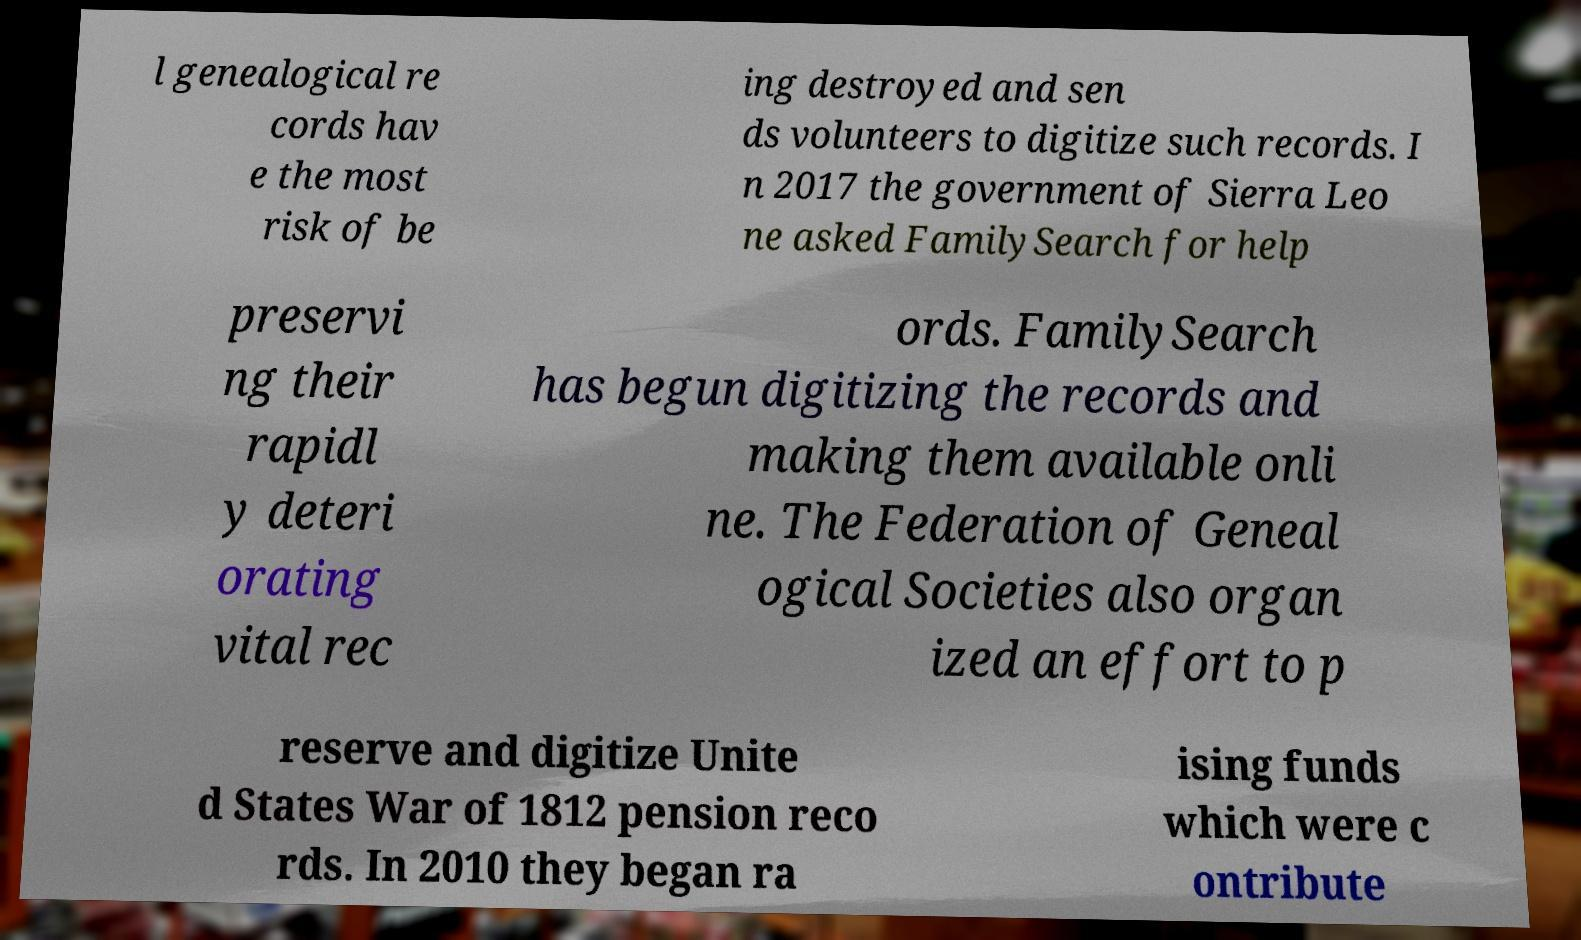Could you assist in decoding the text presented in this image and type it out clearly? l genealogical re cords hav e the most risk of be ing destroyed and sen ds volunteers to digitize such records. I n 2017 the government of Sierra Leo ne asked FamilySearch for help preservi ng their rapidl y deteri orating vital rec ords. FamilySearch has begun digitizing the records and making them available onli ne. The Federation of Geneal ogical Societies also organ ized an effort to p reserve and digitize Unite d States War of 1812 pension reco rds. In 2010 they began ra ising funds which were c ontribute 